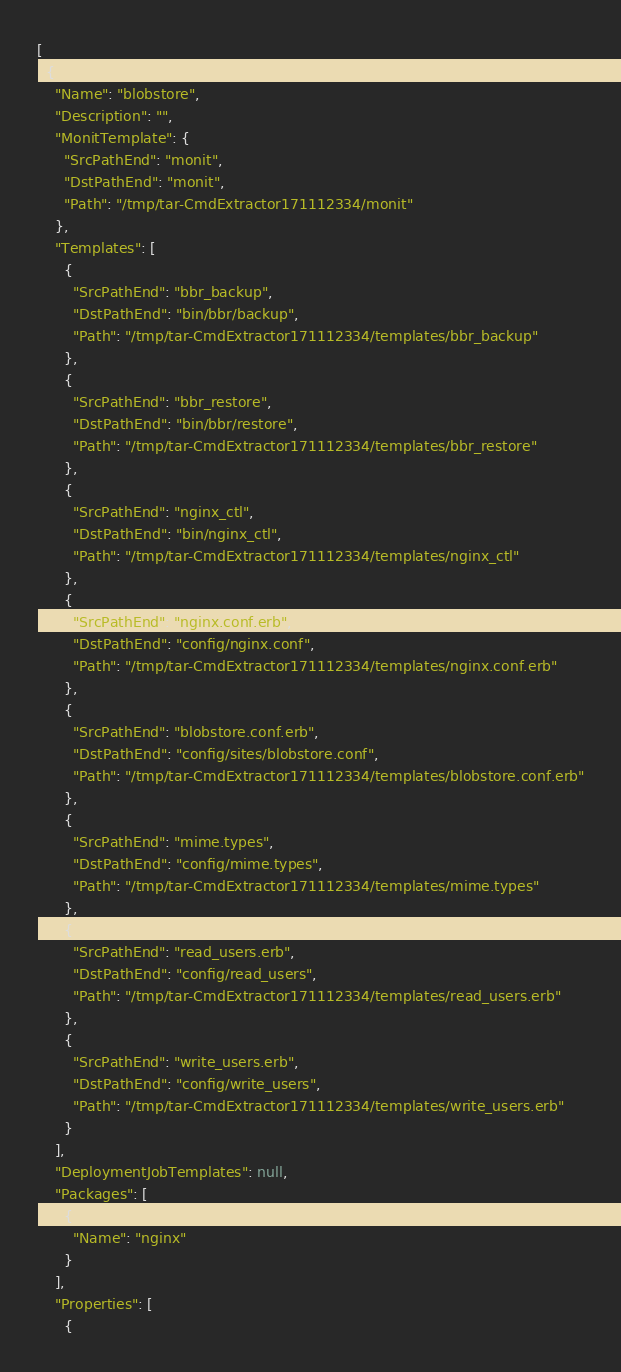Convert code to text. <code><loc_0><loc_0><loc_500><loc_500><_YAML_>[
  {
    "Name": "blobstore",
    "Description": "",
    "MonitTemplate": {
      "SrcPathEnd": "monit",
      "DstPathEnd": "monit",
      "Path": "/tmp/tar-CmdExtractor171112334/monit"
    },
    "Templates": [
      {
        "SrcPathEnd": "bbr_backup",
        "DstPathEnd": "bin/bbr/backup",
        "Path": "/tmp/tar-CmdExtractor171112334/templates/bbr_backup"
      },
      {
        "SrcPathEnd": "bbr_restore",
        "DstPathEnd": "bin/bbr/restore",
        "Path": "/tmp/tar-CmdExtractor171112334/templates/bbr_restore"
      },
      {
        "SrcPathEnd": "nginx_ctl",
        "DstPathEnd": "bin/nginx_ctl",
        "Path": "/tmp/tar-CmdExtractor171112334/templates/nginx_ctl"
      },
      {
        "SrcPathEnd": "nginx.conf.erb",
        "DstPathEnd": "config/nginx.conf",
        "Path": "/tmp/tar-CmdExtractor171112334/templates/nginx.conf.erb"
      },
      {
        "SrcPathEnd": "blobstore.conf.erb",
        "DstPathEnd": "config/sites/blobstore.conf",
        "Path": "/tmp/tar-CmdExtractor171112334/templates/blobstore.conf.erb"
      },
      {
        "SrcPathEnd": "mime.types",
        "DstPathEnd": "config/mime.types",
        "Path": "/tmp/tar-CmdExtractor171112334/templates/mime.types"
      },
      {
        "SrcPathEnd": "read_users.erb",
        "DstPathEnd": "config/read_users",
        "Path": "/tmp/tar-CmdExtractor171112334/templates/read_users.erb"
      },
      {
        "SrcPathEnd": "write_users.erb",
        "DstPathEnd": "config/write_users",
        "Path": "/tmp/tar-CmdExtractor171112334/templates/write_users.erb"
      }
    ],
    "DeploymentJobTemplates": null,
    "Packages": [
      {
        "Name": "nginx"
      }
    ],
    "Properties": [
      {</code> 